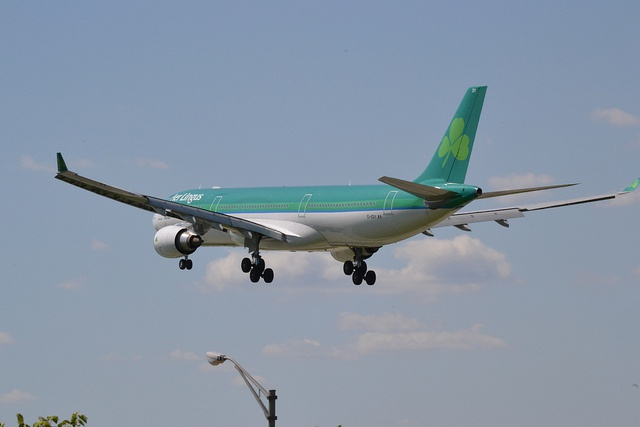Describe the objects in this image and their specific colors. I can see a airplane in gray, teal, black, and darkgray tones in this image. 